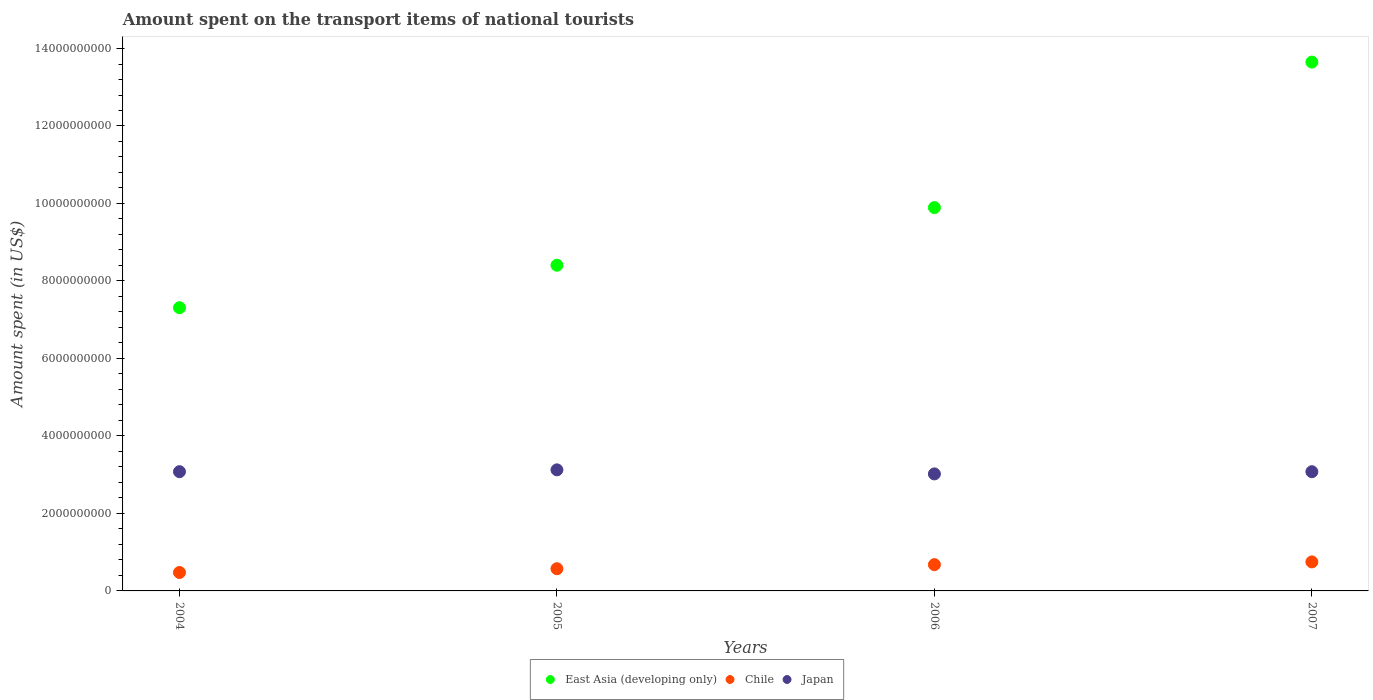Is the number of dotlines equal to the number of legend labels?
Provide a succinct answer. Yes. What is the amount spent on the transport items of national tourists in Japan in 2007?
Offer a very short reply. 3.08e+09. Across all years, what is the maximum amount spent on the transport items of national tourists in East Asia (developing only)?
Provide a short and direct response. 1.36e+1. Across all years, what is the minimum amount spent on the transport items of national tourists in Chile?
Ensure brevity in your answer.  4.76e+08. In which year was the amount spent on the transport items of national tourists in Japan maximum?
Your response must be concise. 2005. What is the total amount spent on the transport items of national tourists in East Asia (developing only) in the graph?
Make the answer very short. 3.93e+1. What is the difference between the amount spent on the transport items of national tourists in East Asia (developing only) in 2004 and that in 2005?
Offer a very short reply. -1.10e+09. What is the difference between the amount spent on the transport items of national tourists in East Asia (developing only) in 2005 and the amount spent on the transport items of national tourists in Chile in 2007?
Make the answer very short. 7.66e+09. What is the average amount spent on the transport items of national tourists in Chile per year?
Keep it short and to the point. 6.19e+08. In the year 2006, what is the difference between the amount spent on the transport items of national tourists in Japan and amount spent on the transport items of national tourists in East Asia (developing only)?
Keep it short and to the point. -6.87e+09. In how many years, is the amount spent on the transport items of national tourists in Chile greater than 1200000000 US$?
Offer a terse response. 0. What is the ratio of the amount spent on the transport items of national tourists in Japan in 2004 to that in 2007?
Offer a very short reply. 1. What is the difference between the highest and the second highest amount spent on the transport items of national tourists in Japan?
Provide a short and direct response. 4.70e+07. What is the difference between the highest and the lowest amount spent on the transport items of national tourists in Chile?
Offer a terse response. 2.73e+08. Is it the case that in every year, the sum of the amount spent on the transport items of national tourists in Chile and amount spent on the transport items of national tourists in Japan  is greater than the amount spent on the transport items of national tourists in East Asia (developing only)?
Keep it short and to the point. No. Is the amount spent on the transport items of national tourists in Chile strictly greater than the amount spent on the transport items of national tourists in East Asia (developing only) over the years?
Offer a terse response. No. Is the amount spent on the transport items of national tourists in East Asia (developing only) strictly less than the amount spent on the transport items of national tourists in Chile over the years?
Ensure brevity in your answer.  No. How many years are there in the graph?
Make the answer very short. 4. What is the difference between two consecutive major ticks on the Y-axis?
Your response must be concise. 2.00e+09. Are the values on the major ticks of Y-axis written in scientific E-notation?
Provide a succinct answer. No. Does the graph contain any zero values?
Offer a very short reply. No. What is the title of the graph?
Give a very brief answer. Amount spent on the transport items of national tourists. Does "Thailand" appear as one of the legend labels in the graph?
Offer a terse response. No. What is the label or title of the Y-axis?
Provide a short and direct response. Amount spent (in US$). What is the Amount spent (in US$) in East Asia (developing only) in 2004?
Offer a terse response. 7.31e+09. What is the Amount spent (in US$) of Chile in 2004?
Your answer should be compact. 4.76e+08. What is the Amount spent (in US$) in Japan in 2004?
Offer a terse response. 3.08e+09. What is the Amount spent (in US$) of East Asia (developing only) in 2005?
Give a very brief answer. 8.41e+09. What is the Amount spent (in US$) of Chile in 2005?
Your answer should be compact. 5.73e+08. What is the Amount spent (in US$) in Japan in 2005?
Ensure brevity in your answer.  3.12e+09. What is the Amount spent (in US$) of East Asia (developing only) in 2006?
Your answer should be compact. 9.89e+09. What is the Amount spent (in US$) of Chile in 2006?
Keep it short and to the point. 6.78e+08. What is the Amount spent (in US$) in Japan in 2006?
Make the answer very short. 3.02e+09. What is the Amount spent (in US$) of East Asia (developing only) in 2007?
Provide a succinct answer. 1.36e+1. What is the Amount spent (in US$) in Chile in 2007?
Provide a short and direct response. 7.49e+08. What is the Amount spent (in US$) in Japan in 2007?
Your answer should be very brief. 3.08e+09. Across all years, what is the maximum Amount spent (in US$) in East Asia (developing only)?
Provide a succinct answer. 1.36e+1. Across all years, what is the maximum Amount spent (in US$) of Chile?
Your response must be concise. 7.49e+08. Across all years, what is the maximum Amount spent (in US$) of Japan?
Keep it short and to the point. 3.12e+09. Across all years, what is the minimum Amount spent (in US$) in East Asia (developing only)?
Make the answer very short. 7.31e+09. Across all years, what is the minimum Amount spent (in US$) of Chile?
Offer a terse response. 4.76e+08. Across all years, what is the minimum Amount spent (in US$) of Japan?
Offer a terse response. 3.02e+09. What is the total Amount spent (in US$) of East Asia (developing only) in the graph?
Offer a terse response. 3.93e+1. What is the total Amount spent (in US$) in Chile in the graph?
Offer a very short reply. 2.48e+09. What is the total Amount spent (in US$) of Japan in the graph?
Give a very brief answer. 1.23e+1. What is the difference between the Amount spent (in US$) of East Asia (developing only) in 2004 and that in 2005?
Ensure brevity in your answer.  -1.10e+09. What is the difference between the Amount spent (in US$) in Chile in 2004 and that in 2005?
Provide a succinct answer. -9.70e+07. What is the difference between the Amount spent (in US$) of Japan in 2004 and that in 2005?
Offer a terse response. -4.70e+07. What is the difference between the Amount spent (in US$) in East Asia (developing only) in 2004 and that in 2006?
Provide a succinct answer. -2.58e+09. What is the difference between the Amount spent (in US$) in Chile in 2004 and that in 2006?
Your response must be concise. -2.02e+08. What is the difference between the Amount spent (in US$) in Japan in 2004 and that in 2006?
Your answer should be compact. 5.80e+07. What is the difference between the Amount spent (in US$) of East Asia (developing only) in 2004 and that in 2007?
Give a very brief answer. -6.34e+09. What is the difference between the Amount spent (in US$) of Chile in 2004 and that in 2007?
Ensure brevity in your answer.  -2.73e+08. What is the difference between the Amount spent (in US$) of Japan in 2004 and that in 2007?
Provide a short and direct response. 1.00e+06. What is the difference between the Amount spent (in US$) of East Asia (developing only) in 2005 and that in 2006?
Your answer should be compact. -1.49e+09. What is the difference between the Amount spent (in US$) in Chile in 2005 and that in 2006?
Keep it short and to the point. -1.05e+08. What is the difference between the Amount spent (in US$) of Japan in 2005 and that in 2006?
Ensure brevity in your answer.  1.05e+08. What is the difference between the Amount spent (in US$) of East Asia (developing only) in 2005 and that in 2007?
Your response must be concise. -5.24e+09. What is the difference between the Amount spent (in US$) of Chile in 2005 and that in 2007?
Offer a terse response. -1.76e+08. What is the difference between the Amount spent (in US$) of Japan in 2005 and that in 2007?
Make the answer very short. 4.80e+07. What is the difference between the Amount spent (in US$) in East Asia (developing only) in 2006 and that in 2007?
Provide a succinct answer. -3.76e+09. What is the difference between the Amount spent (in US$) in Chile in 2006 and that in 2007?
Provide a succinct answer. -7.10e+07. What is the difference between the Amount spent (in US$) of Japan in 2006 and that in 2007?
Your response must be concise. -5.70e+07. What is the difference between the Amount spent (in US$) of East Asia (developing only) in 2004 and the Amount spent (in US$) of Chile in 2005?
Your answer should be compact. 6.74e+09. What is the difference between the Amount spent (in US$) of East Asia (developing only) in 2004 and the Amount spent (in US$) of Japan in 2005?
Provide a short and direct response. 4.19e+09. What is the difference between the Amount spent (in US$) of Chile in 2004 and the Amount spent (in US$) of Japan in 2005?
Ensure brevity in your answer.  -2.65e+09. What is the difference between the Amount spent (in US$) of East Asia (developing only) in 2004 and the Amount spent (in US$) of Chile in 2006?
Offer a terse response. 6.63e+09. What is the difference between the Amount spent (in US$) of East Asia (developing only) in 2004 and the Amount spent (in US$) of Japan in 2006?
Your response must be concise. 4.29e+09. What is the difference between the Amount spent (in US$) in Chile in 2004 and the Amount spent (in US$) in Japan in 2006?
Ensure brevity in your answer.  -2.54e+09. What is the difference between the Amount spent (in US$) of East Asia (developing only) in 2004 and the Amount spent (in US$) of Chile in 2007?
Give a very brief answer. 6.56e+09. What is the difference between the Amount spent (in US$) in East Asia (developing only) in 2004 and the Amount spent (in US$) in Japan in 2007?
Your answer should be very brief. 4.23e+09. What is the difference between the Amount spent (in US$) in Chile in 2004 and the Amount spent (in US$) in Japan in 2007?
Ensure brevity in your answer.  -2.60e+09. What is the difference between the Amount spent (in US$) of East Asia (developing only) in 2005 and the Amount spent (in US$) of Chile in 2006?
Your answer should be very brief. 7.73e+09. What is the difference between the Amount spent (in US$) in East Asia (developing only) in 2005 and the Amount spent (in US$) in Japan in 2006?
Provide a succinct answer. 5.39e+09. What is the difference between the Amount spent (in US$) of Chile in 2005 and the Amount spent (in US$) of Japan in 2006?
Offer a terse response. -2.45e+09. What is the difference between the Amount spent (in US$) of East Asia (developing only) in 2005 and the Amount spent (in US$) of Chile in 2007?
Your answer should be very brief. 7.66e+09. What is the difference between the Amount spent (in US$) in East Asia (developing only) in 2005 and the Amount spent (in US$) in Japan in 2007?
Offer a terse response. 5.33e+09. What is the difference between the Amount spent (in US$) in Chile in 2005 and the Amount spent (in US$) in Japan in 2007?
Offer a terse response. -2.50e+09. What is the difference between the Amount spent (in US$) in East Asia (developing only) in 2006 and the Amount spent (in US$) in Chile in 2007?
Your response must be concise. 9.14e+09. What is the difference between the Amount spent (in US$) of East Asia (developing only) in 2006 and the Amount spent (in US$) of Japan in 2007?
Keep it short and to the point. 6.82e+09. What is the difference between the Amount spent (in US$) of Chile in 2006 and the Amount spent (in US$) of Japan in 2007?
Offer a terse response. -2.40e+09. What is the average Amount spent (in US$) of East Asia (developing only) per year?
Provide a succinct answer. 9.82e+09. What is the average Amount spent (in US$) in Chile per year?
Make the answer very short. 6.19e+08. What is the average Amount spent (in US$) in Japan per year?
Your response must be concise. 3.08e+09. In the year 2004, what is the difference between the Amount spent (in US$) of East Asia (developing only) and Amount spent (in US$) of Chile?
Your response must be concise. 6.83e+09. In the year 2004, what is the difference between the Amount spent (in US$) in East Asia (developing only) and Amount spent (in US$) in Japan?
Ensure brevity in your answer.  4.23e+09. In the year 2004, what is the difference between the Amount spent (in US$) of Chile and Amount spent (in US$) of Japan?
Your answer should be very brief. -2.60e+09. In the year 2005, what is the difference between the Amount spent (in US$) of East Asia (developing only) and Amount spent (in US$) of Chile?
Ensure brevity in your answer.  7.83e+09. In the year 2005, what is the difference between the Amount spent (in US$) of East Asia (developing only) and Amount spent (in US$) of Japan?
Provide a succinct answer. 5.28e+09. In the year 2005, what is the difference between the Amount spent (in US$) in Chile and Amount spent (in US$) in Japan?
Your answer should be compact. -2.55e+09. In the year 2006, what is the difference between the Amount spent (in US$) in East Asia (developing only) and Amount spent (in US$) in Chile?
Provide a short and direct response. 9.22e+09. In the year 2006, what is the difference between the Amount spent (in US$) of East Asia (developing only) and Amount spent (in US$) of Japan?
Provide a succinct answer. 6.87e+09. In the year 2006, what is the difference between the Amount spent (in US$) of Chile and Amount spent (in US$) of Japan?
Your answer should be very brief. -2.34e+09. In the year 2007, what is the difference between the Amount spent (in US$) of East Asia (developing only) and Amount spent (in US$) of Chile?
Make the answer very short. 1.29e+1. In the year 2007, what is the difference between the Amount spent (in US$) in East Asia (developing only) and Amount spent (in US$) in Japan?
Keep it short and to the point. 1.06e+1. In the year 2007, what is the difference between the Amount spent (in US$) of Chile and Amount spent (in US$) of Japan?
Your response must be concise. -2.33e+09. What is the ratio of the Amount spent (in US$) in East Asia (developing only) in 2004 to that in 2005?
Your response must be concise. 0.87. What is the ratio of the Amount spent (in US$) in Chile in 2004 to that in 2005?
Ensure brevity in your answer.  0.83. What is the ratio of the Amount spent (in US$) in Japan in 2004 to that in 2005?
Provide a short and direct response. 0.98. What is the ratio of the Amount spent (in US$) in East Asia (developing only) in 2004 to that in 2006?
Provide a succinct answer. 0.74. What is the ratio of the Amount spent (in US$) of Chile in 2004 to that in 2006?
Ensure brevity in your answer.  0.7. What is the ratio of the Amount spent (in US$) of Japan in 2004 to that in 2006?
Your answer should be very brief. 1.02. What is the ratio of the Amount spent (in US$) in East Asia (developing only) in 2004 to that in 2007?
Offer a terse response. 0.54. What is the ratio of the Amount spent (in US$) in Chile in 2004 to that in 2007?
Make the answer very short. 0.64. What is the ratio of the Amount spent (in US$) in Japan in 2004 to that in 2007?
Ensure brevity in your answer.  1. What is the ratio of the Amount spent (in US$) in East Asia (developing only) in 2005 to that in 2006?
Offer a very short reply. 0.85. What is the ratio of the Amount spent (in US$) in Chile in 2005 to that in 2006?
Ensure brevity in your answer.  0.85. What is the ratio of the Amount spent (in US$) in Japan in 2005 to that in 2006?
Your answer should be very brief. 1.03. What is the ratio of the Amount spent (in US$) of East Asia (developing only) in 2005 to that in 2007?
Give a very brief answer. 0.62. What is the ratio of the Amount spent (in US$) in Chile in 2005 to that in 2007?
Keep it short and to the point. 0.77. What is the ratio of the Amount spent (in US$) of Japan in 2005 to that in 2007?
Your answer should be compact. 1.02. What is the ratio of the Amount spent (in US$) in East Asia (developing only) in 2006 to that in 2007?
Provide a short and direct response. 0.72. What is the ratio of the Amount spent (in US$) in Chile in 2006 to that in 2007?
Offer a very short reply. 0.91. What is the ratio of the Amount spent (in US$) of Japan in 2006 to that in 2007?
Offer a very short reply. 0.98. What is the difference between the highest and the second highest Amount spent (in US$) in East Asia (developing only)?
Provide a succinct answer. 3.76e+09. What is the difference between the highest and the second highest Amount spent (in US$) in Chile?
Keep it short and to the point. 7.10e+07. What is the difference between the highest and the second highest Amount spent (in US$) in Japan?
Keep it short and to the point. 4.70e+07. What is the difference between the highest and the lowest Amount spent (in US$) of East Asia (developing only)?
Provide a succinct answer. 6.34e+09. What is the difference between the highest and the lowest Amount spent (in US$) in Chile?
Give a very brief answer. 2.73e+08. What is the difference between the highest and the lowest Amount spent (in US$) in Japan?
Your answer should be very brief. 1.05e+08. 